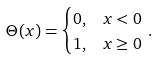<formula> <loc_0><loc_0><loc_500><loc_500>\Theta ( x ) & = \begin{cases} 0 , & x < 0 \\ 1 , & x \geq 0 \\ \end{cases} \, .</formula> 